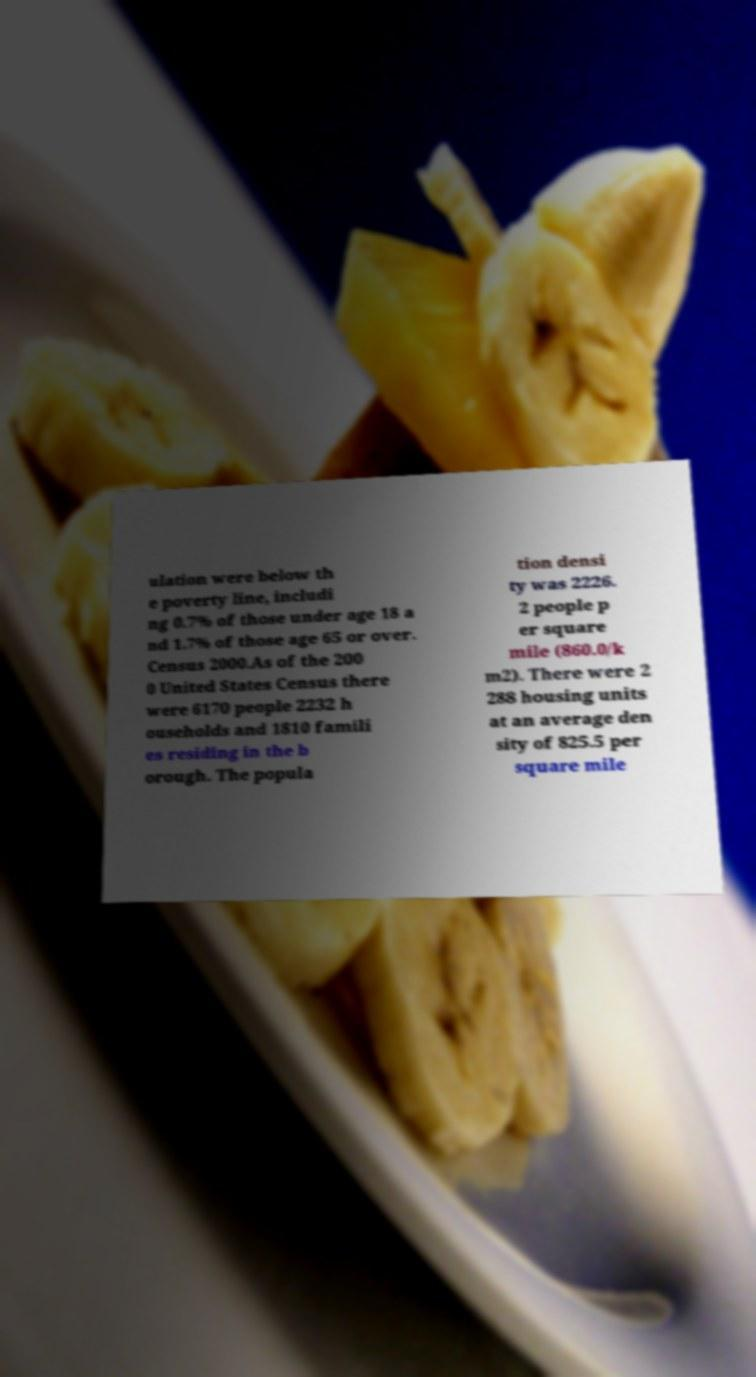Could you assist in decoding the text presented in this image and type it out clearly? ulation were below th e poverty line, includi ng 0.7% of those under age 18 a nd 1.7% of those age 65 or over. Census 2000.As of the 200 0 United States Census there were 6170 people 2232 h ouseholds and 1810 famili es residing in the b orough. The popula tion densi ty was 2226. 2 people p er square mile (860.0/k m2). There were 2 288 housing units at an average den sity of 825.5 per square mile 